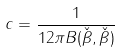Convert formula to latex. <formula><loc_0><loc_0><loc_500><loc_500>c = \frac { 1 } { 1 2 \pi B ( \check { \beta } , \check { \beta } ) }</formula> 